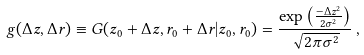Convert formula to latex. <formula><loc_0><loc_0><loc_500><loc_500>g ( \Delta z , \Delta r ) \equiv G ( z _ { 0 } + \Delta z , r _ { 0 } + \Delta r | z _ { 0 } , r _ { 0 } ) = \frac { \exp \left ( \frac { - \Delta z ^ { 2 } } { 2 \sigma ^ { 2 } } \right ) } { \sqrt { 2 \pi \sigma ^ { 2 } } } \, ,</formula> 